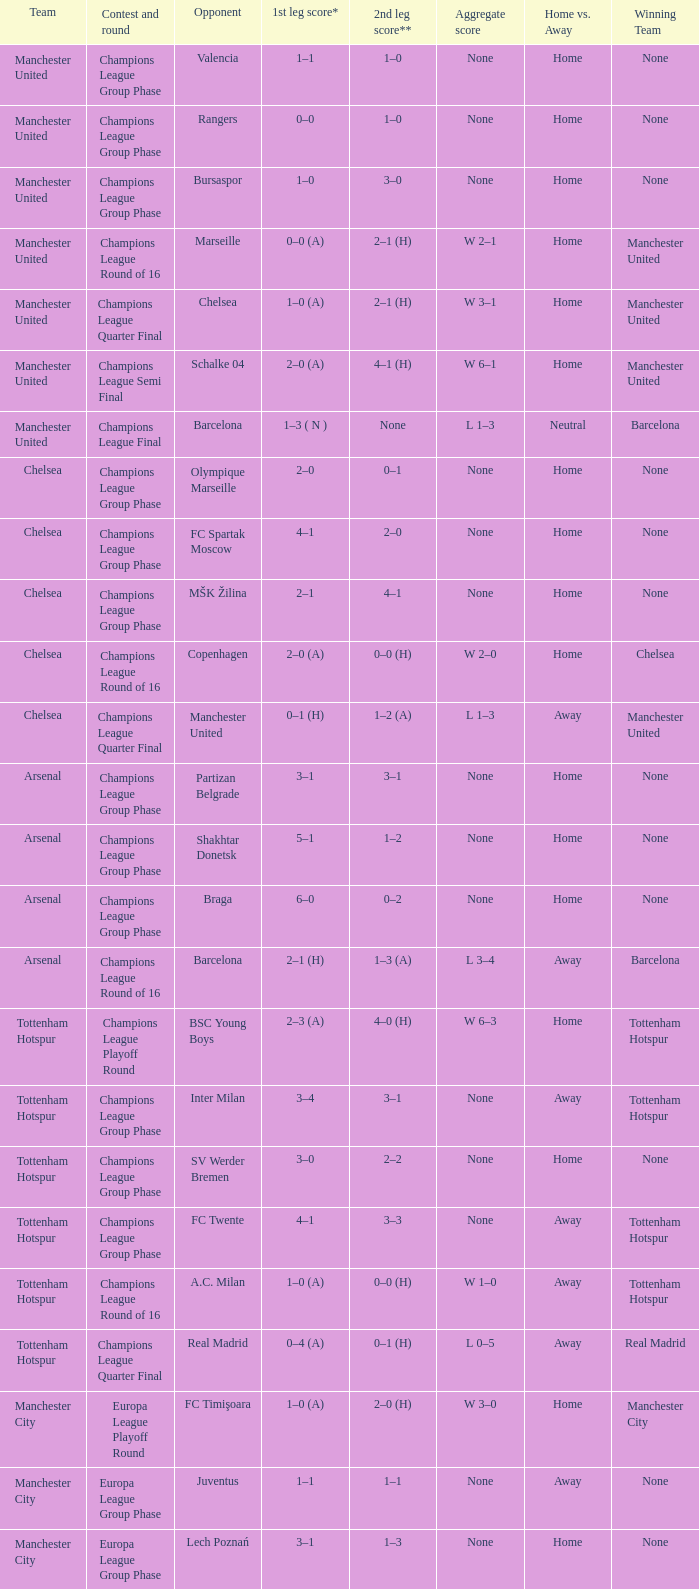How many goals did each one of the teams score in the first leg of the match between Liverpool and Trabzonspor? 1–0 (H). 